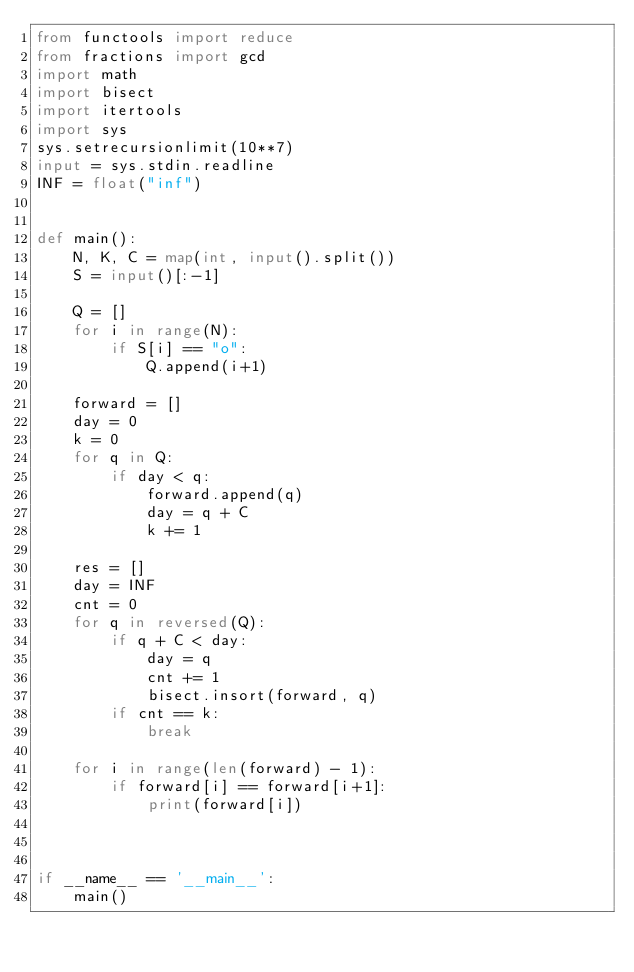Convert code to text. <code><loc_0><loc_0><loc_500><loc_500><_Python_>from functools import reduce
from fractions import gcd
import math
import bisect
import itertools
import sys
sys.setrecursionlimit(10**7)
input = sys.stdin.readline
INF = float("inf")


def main():
    N, K, C = map(int, input().split())
    S = input()[:-1]

    Q = []
    for i in range(N):
        if S[i] == "o":
            Q.append(i+1)

    forward = []
    day = 0
    k = 0
    for q in Q:
        if day < q:
            forward.append(q)
            day = q + C
            k += 1
    
    res = []
    day = INF
    cnt = 0
    for q in reversed(Q):
        if q + C < day:
            day = q
            cnt += 1
            bisect.insort(forward, q)
        if cnt == k:
            break
    
    for i in range(len(forward) - 1):
        if forward[i] == forward[i+1]:
            print(forward[i])
        


if __name__ == '__main__':
    main()</code> 